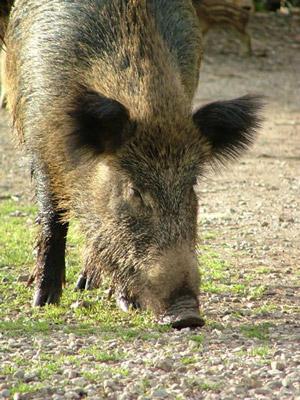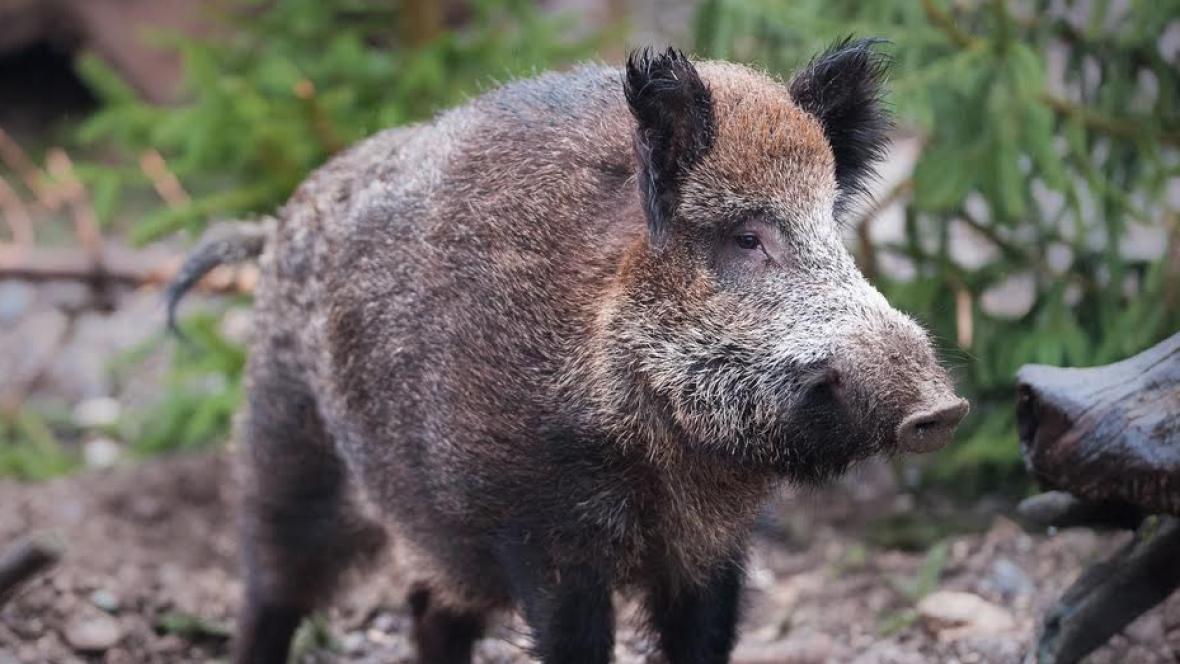The first image is the image on the left, the second image is the image on the right. Considering the images on both sides, is "In at least one image there is a black eared boar with there body facing right while it's snout is facing forward left." valid? Answer yes or no. No. The first image is the image on the left, the second image is the image on the right. For the images displayed, is the sentence "One image shows a forward-turned wild pig without visible tusks, standing on elevated ground and looking downward." factually correct? Answer yes or no. No. 